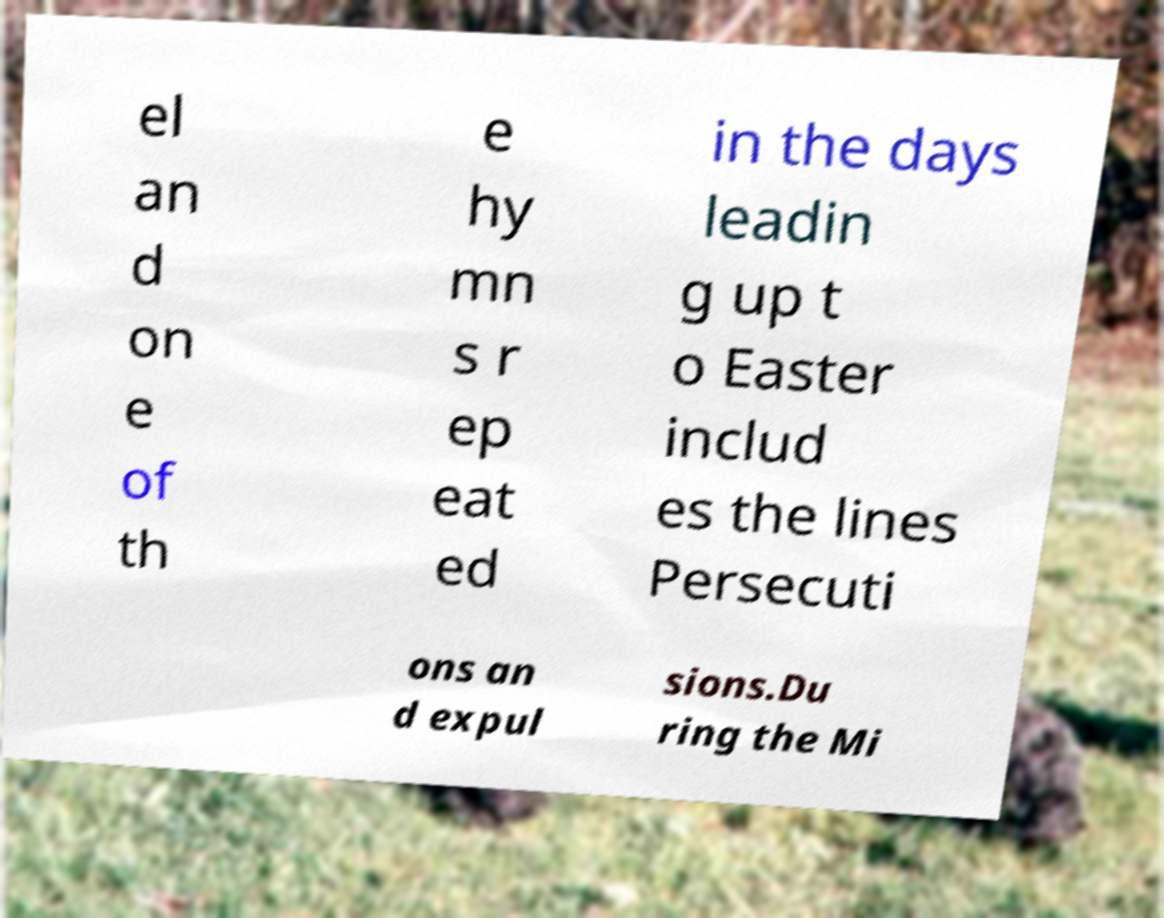What messages or text are displayed in this image? I need them in a readable, typed format. el an d on e of th e hy mn s r ep eat ed in the days leadin g up t o Easter includ es the lines Persecuti ons an d expul sions.Du ring the Mi 